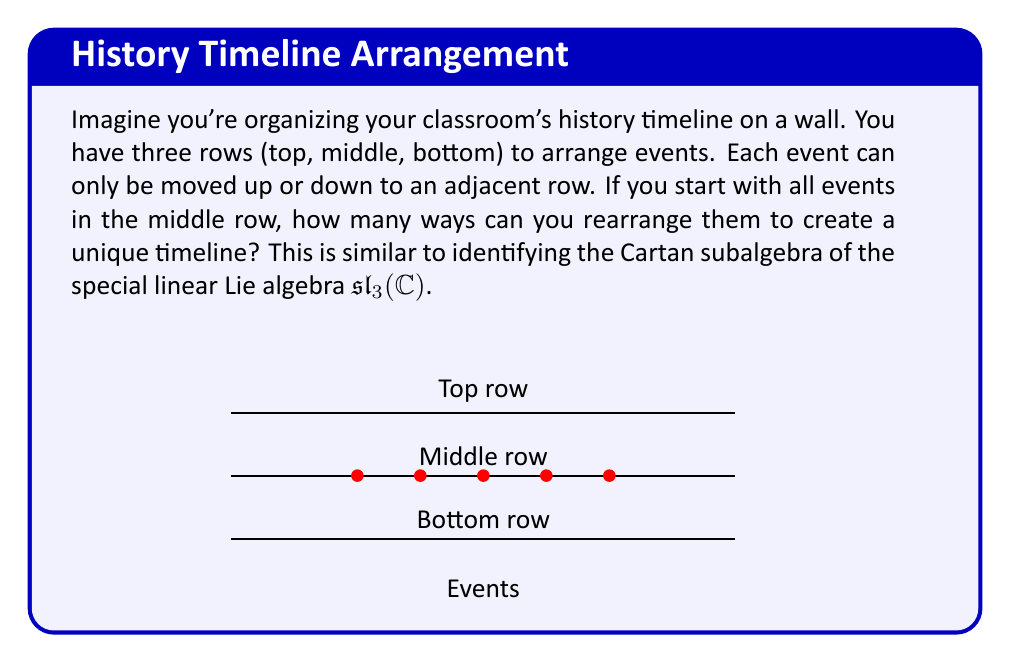Give your solution to this math problem. While this question seems to be about arranging history events, it's actually related to the Cartan subalgebra of $\mathfrak{sl}_3(\mathbb{C})$. Let's break it down:

1) In $\mathfrak{sl}_3(\mathbb{C})$, we're dealing with 3x3 traceless matrices. The Cartan subalgebra consists of diagonal matrices with trace zero.

2) A general element of the Cartan subalgebra looks like:

   $$\begin{pmatrix}
   a & 0 & 0\\
   0 & b & 0\\
   0 & 0 & -(a+b)
   \end{pmatrix}$$

3) This corresponds to our timeline arrangement:
   - Top row: $a$
   - Middle row: $b$
   - Bottom row: $-(a+b)$

4) The constraint that the sum must be zero (trace = 0) is similar to the fact that all events must be placed in one of the three rows.

5) The dimension of the Cartan subalgebra is the number of independent parameters. Here, we have two: $a$ and $b$.

6) This is equivalent to asking: how many ways can we arrange the events if we can only move them up or down by one row from the middle?

7) The answer is 2, corresponding to the two independent parameters $a$ and $b$.
Answer: 2-dimensional 